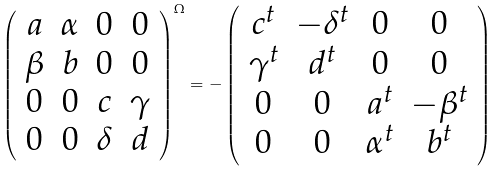Convert formula to latex. <formula><loc_0><loc_0><loc_500><loc_500>\left ( \begin{array} { c c c c } a & \alpha & 0 & 0 \\ \beta & b & 0 & 0 \\ 0 & 0 & c & \gamma \\ 0 & 0 & \delta & d \end{array} \right ) ^ { \Omega } = - \left ( \begin{array} { c c c c } c ^ { t } & - \delta ^ { t } & 0 & 0 \\ \gamma ^ { t } & d ^ { t } & 0 & 0 \\ 0 & 0 & a ^ { t } & - \beta ^ { t } \\ 0 & 0 & \alpha ^ { t } & b ^ { t } \end{array} \right )</formula> 